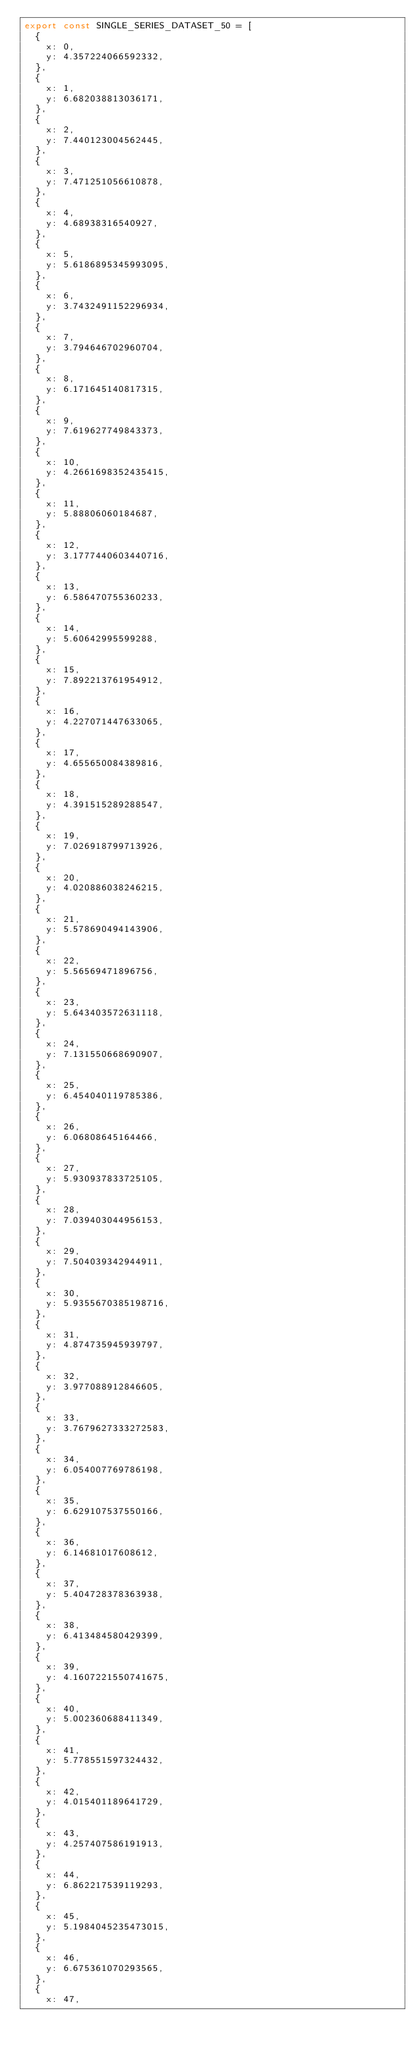Convert code to text. <code><loc_0><loc_0><loc_500><loc_500><_TypeScript_>export const SINGLE_SERIES_DATASET_50 = [
  {
    x: 0,
    y: 4.357224066592332,
  },
  {
    x: 1,
    y: 6.682038813036171,
  },
  {
    x: 2,
    y: 7.440123004562445,
  },
  {
    x: 3,
    y: 7.471251056610878,
  },
  {
    x: 4,
    y: 4.68938316540927,
  },
  {
    x: 5,
    y: 5.6186895345993095,
  },
  {
    x: 6,
    y: 3.7432491152296934,
  },
  {
    x: 7,
    y: 3.794646702960704,
  },
  {
    x: 8,
    y: 6.171645140817315,
  },
  {
    x: 9,
    y: 7.619627749843373,
  },
  {
    x: 10,
    y: 4.2661698352435415,
  },
  {
    x: 11,
    y: 5.88806060184687,
  },
  {
    x: 12,
    y: 3.1777440603440716,
  },
  {
    x: 13,
    y: 6.586470755360233,
  },
  {
    x: 14,
    y: 5.60642995599288,
  },
  {
    x: 15,
    y: 7.892213761954912,
  },
  {
    x: 16,
    y: 4.227071447633065,
  },
  {
    x: 17,
    y: 4.655650084389816,
  },
  {
    x: 18,
    y: 4.391515289288547,
  },
  {
    x: 19,
    y: 7.026918799713926,
  },
  {
    x: 20,
    y: 4.020886038246215,
  },
  {
    x: 21,
    y: 5.578690494143906,
  },
  {
    x: 22,
    y: 5.56569471896756,
  },
  {
    x: 23,
    y: 5.643403572631118,
  },
  {
    x: 24,
    y: 7.131550668690907,
  },
  {
    x: 25,
    y: 6.454040119785386,
  },
  {
    x: 26,
    y: 6.06808645164466,
  },
  {
    x: 27,
    y: 5.930937833725105,
  },
  {
    x: 28,
    y: 7.039403044956153,
  },
  {
    x: 29,
    y: 7.504039342944911,
  },
  {
    x: 30,
    y: 5.9355670385198716,
  },
  {
    x: 31,
    y: 4.874735945939797,
  },
  {
    x: 32,
    y: 3.977088912846605,
  },
  {
    x: 33,
    y: 3.7679627333272583,
  },
  {
    x: 34,
    y: 6.054007769786198,
  },
  {
    x: 35,
    y: 6.629107537550166,
  },
  {
    x: 36,
    y: 6.14681017608612,
  },
  {
    x: 37,
    y: 5.404728378363938,
  },
  {
    x: 38,
    y: 6.413484580429399,
  },
  {
    x: 39,
    y: 4.1607221550741675,
  },
  {
    x: 40,
    y: 5.002360688411349,
  },
  {
    x: 41,
    y: 5.778551597324432,
  },
  {
    x: 42,
    y: 4.015401189641729,
  },
  {
    x: 43,
    y: 4.257407586191913,
  },
  {
    x: 44,
    y: 6.862217539119293,
  },
  {
    x: 45,
    y: 5.1984045235473015,
  },
  {
    x: 46,
    y: 6.675361070293565,
  },
  {
    x: 47,</code> 